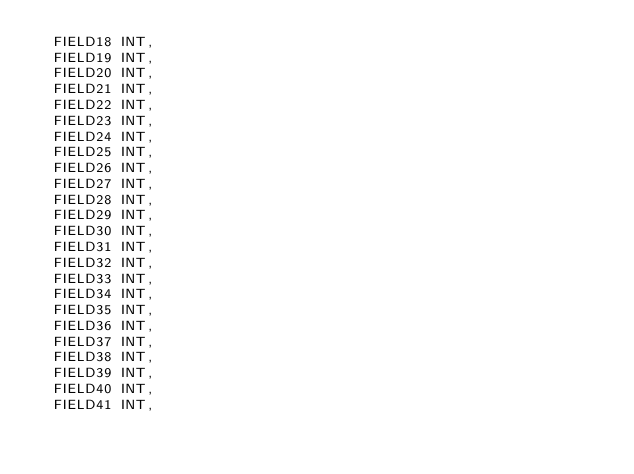Convert code to text. <code><loc_0><loc_0><loc_500><loc_500><_SQL_>	FIELD18 INT,
	FIELD19 INT,
	FIELD20 INT,
	FIELD21 INT,
	FIELD22 INT,
	FIELD23 INT,
	FIELD24 INT,
	FIELD25 INT,
	FIELD26 INT,
	FIELD27 INT,
	FIELD28 INT,
	FIELD29 INT,
	FIELD30 INT,
	FIELD31 INT,
	FIELD32 INT,
	FIELD33 INT,
	FIELD34 INT,
	FIELD35 INT,
	FIELD36 INT,
	FIELD37 INT,
	FIELD38 INT,
	FIELD39 INT,
	FIELD40 INT,
	FIELD41 INT,</code> 